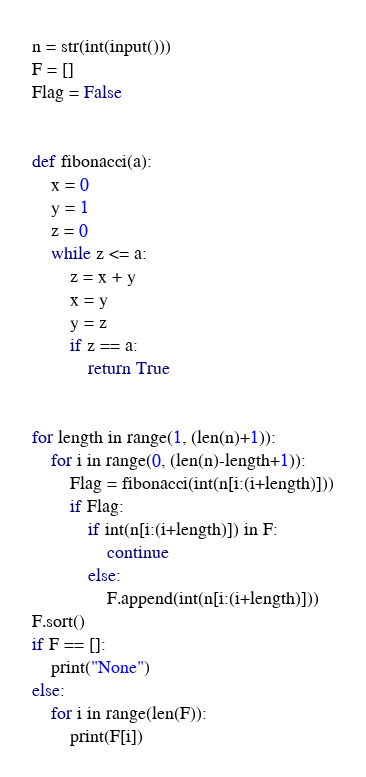Convert code to text. <code><loc_0><loc_0><loc_500><loc_500><_Python_>n = str(int(input()))
F = []
Flag = False


def fibonacci(a):
    x = 0
    y = 1
    z = 0
    while z <= a:
        z = x + y
        x = y
        y = z
        if z == a:
            return True


for length in range(1, (len(n)+1)):
    for i in range(0, (len(n)-length+1)):
        Flag = fibonacci(int(n[i:(i+length)]))
        if Flag:
            if int(n[i:(i+length)]) in F:
                continue
            else:
                F.append(int(n[i:(i+length)]))
F.sort()
if F == []:
    print("None")
else:
    for i in range(len(F)):
        print(F[i])

</code> 